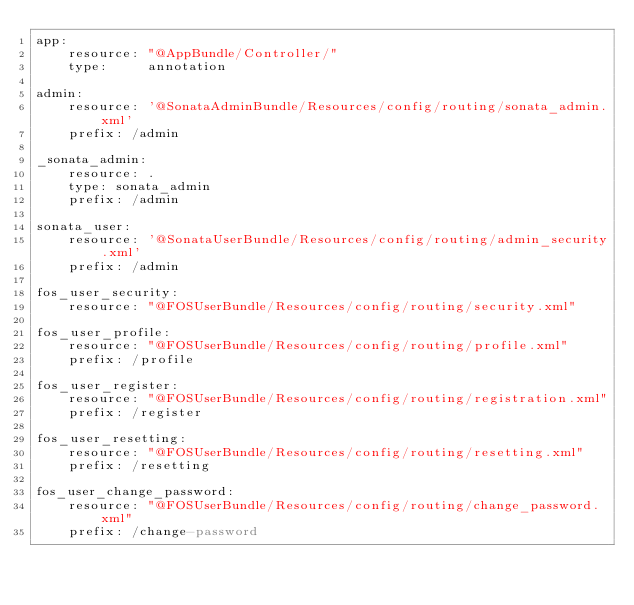<code> <loc_0><loc_0><loc_500><loc_500><_YAML_>app:
    resource: "@AppBundle/Controller/"
    type:     annotation

admin:
    resource: '@SonataAdminBundle/Resources/config/routing/sonata_admin.xml'
    prefix: /admin

_sonata_admin:
    resource: .
    type: sonata_admin
    prefix: /admin

sonata_user:
    resource: '@SonataUserBundle/Resources/config/routing/admin_security.xml'
    prefix: /admin

fos_user_security:
    resource: "@FOSUserBundle/Resources/config/routing/security.xml"

fos_user_profile:
    resource: "@FOSUserBundle/Resources/config/routing/profile.xml"
    prefix: /profile

fos_user_register:
    resource: "@FOSUserBundle/Resources/config/routing/registration.xml"
    prefix: /register

fos_user_resetting:
    resource: "@FOSUserBundle/Resources/config/routing/resetting.xml"
    prefix: /resetting

fos_user_change_password:
    resource: "@FOSUserBundle/Resources/config/routing/change_password.xml"
    prefix: /change-password</code> 